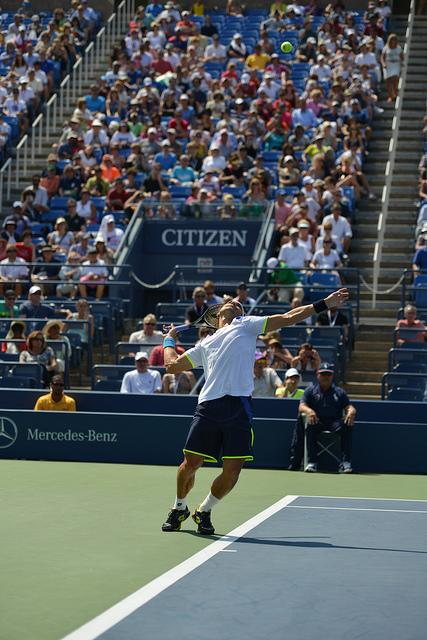What type action is the tennis player here doing? Please explain your reasoning. serving. The stance the guy has is that of the player who is about the serve the ball. 